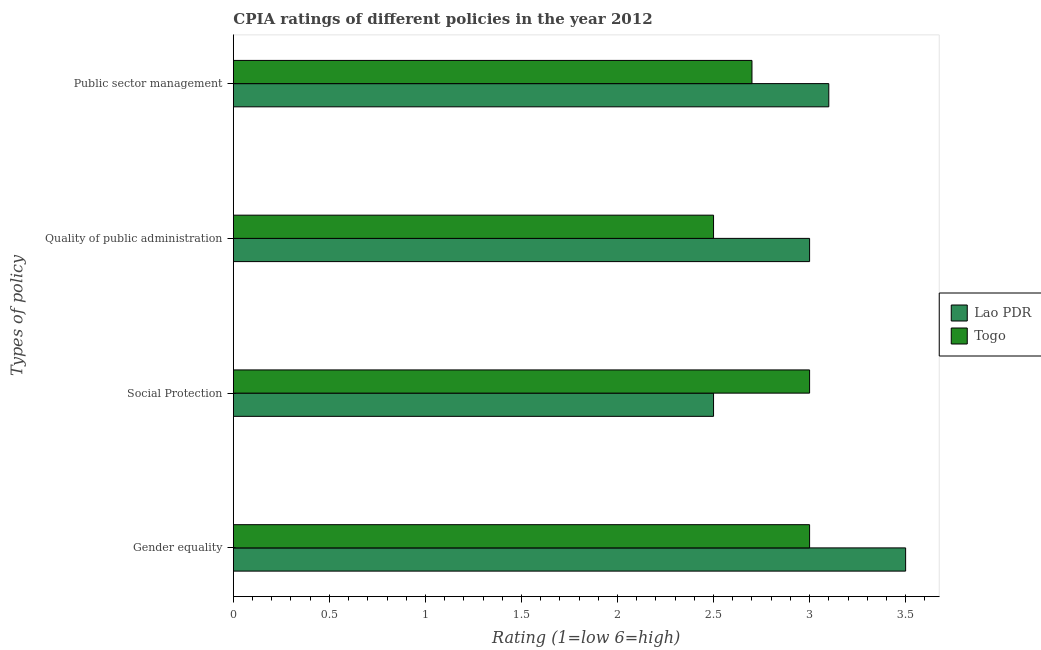How many groups of bars are there?
Your response must be concise. 4. Are the number of bars on each tick of the Y-axis equal?
Give a very brief answer. Yes. What is the label of the 3rd group of bars from the top?
Give a very brief answer. Social Protection. Across all countries, what is the maximum cpia rating of quality of public administration?
Provide a short and direct response. 3. Across all countries, what is the minimum cpia rating of social protection?
Keep it short and to the point. 2.5. In which country was the cpia rating of public sector management maximum?
Make the answer very short. Lao PDR. In which country was the cpia rating of gender equality minimum?
Make the answer very short. Togo. What is the difference between the cpia rating of public sector management in Lao PDR and the cpia rating of quality of public administration in Togo?
Provide a succinct answer. 0.6. What is the difference between the cpia rating of quality of public administration and cpia rating of public sector management in Lao PDR?
Ensure brevity in your answer.  -0.1. In how many countries, is the cpia rating of quality of public administration greater than 2.6 ?
Keep it short and to the point. 1. What is the ratio of the cpia rating of public sector management in Togo to that in Lao PDR?
Offer a terse response. 0.87. Is the cpia rating of social protection in Togo less than that in Lao PDR?
Your answer should be compact. No. What is the difference between the highest and the lowest cpia rating of quality of public administration?
Give a very brief answer. 0.5. In how many countries, is the cpia rating of quality of public administration greater than the average cpia rating of quality of public administration taken over all countries?
Provide a short and direct response. 1. Is the sum of the cpia rating of gender equality in Lao PDR and Togo greater than the maximum cpia rating of social protection across all countries?
Your response must be concise. Yes. What does the 2nd bar from the top in Social Protection represents?
Offer a very short reply. Lao PDR. What does the 2nd bar from the bottom in Gender equality represents?
Provide a succinct answer. Togo. Is it the case that in every country, the sum of the cpia rating of gender equality and cpia rating of social protection is greater than the cpia rating of quality of public administration?
Make the answer very short. Yes. Are all the bars in the graph horizontal?
Offer a very short reply. Yes. What is the difference between two consecutive major ticks on the X-axis?
Your answer should be very brief. 0.5. Where does the legend appear in the graph?
Your answer should be very brief. Center right. How many legend labels are there?
Offer a very short reply. 2. How are the legend labels stacked?
Keep it short and to the point. Vertical. What is the title of the graph?
Make the answer very short. CPIA ratings of different policies in the year 2012. Does "Mozambique" appear as one of the legend labels in the graph?
Provide a succinct answer. No. What is the label or title of the X-axis?
Offer a terse response. Rating (1=low 6=high). What is the label or title of the Y-axis?
Ensure brevity in your answer.  Types of policy. What is the Rating (1=low 6=high) in Togo in Social Protection?
Your response must be concise. 3. What is the Rating (1=low 6=high) in Lao PDR in Quality of public administration?
Your answer should be very brief. 3. What is the Rating (1=low 6=high) in Lao PDR in Public sector management?
Offer a very short reply. 3.1. What is the Rating (1=low 6=high) of Togo in Public sector management?
Your answer should be compact. 2.7. Across all Types of policy, what is the minimum Rating (1=low 6=high) in Lao PDR?
Provide a succinct answer. 2.5. What is the total Rating (1=low 6=high) of Lao PDR in the graph?
Your response must be concise. 12.1. What is the difference between the Rating (1=low 6=high) of Lao PDR in Gender equality and that in Social Protection?
Make the answer very short. 1. What is the difference between the Rating (1=low 6=high) in Lao PDR in Gender equality and that in Public sector management?
Provide a short and direct response. 0.4. What is the difference between the Rating (1=low 6=high) in Lao PDR in Social Protection and that in Quality of public administration?
Your answer should be compact. -0.5. What is the difference between the Rating (1=low 6=high) of Togo in Social Protection and that in Quality of public administration?
Ensure brevity in your answer.  0.5. What is the difference between the Rating (1=low 6=high) of Togo in Social Protection and that in Public sector management?
Provide a short and direct response. 0.3. What is the difference between the Rating (1=low 6=high) in Lao PDR in Quality of public administration and that in Public sector management?
Offer a terse response. -0.1. What is the average Rating (1=low 6=high) in Lao PDR per Types of policy?
Give a very brief answer. 3.02. What is the average Rating (1=low 6=high) of Togo per Types of policy?
Provide a short and direct response. 2.8. What is the difference between the Rating (1=low 6=high) of Lao PDR and Rating (1=low 6=high) of Togo in Social Protection?
Your answer should be compact. -0.5. What is the difference between the Rating (1=low 6=high) in Lao PDR and Rating (1=low 6=high) in Togo in Quality of public administration?
Ensure brevity in your answer.  0.5. What is the ratio of the Rating (1=low 6=high) of Lao PDR in Gender equality to that in Quality of public administration?
Your answer should be compact. 1.17. What is the ratio of the Rating (1=low 6=high) of Togo in Gender equality to that in Quality of public administration?
Your answer should be very brief. 1.2. What is the ratio of the Rating (1=low 6=high) in Lao PDR in Gender equality to that in Public sector management?
Make the answer very short. 1.13. What is the ratio of the Rating (1=low 6=high) of Togo in Gender equality to that in Public sector management?
Your answer should be very brief. 1.11. What is the ratio of the Rating (1=low 6=high) of Togo in Social Protection to that in Quality of public administration?
Offer a very short reply. 1.2. What is the ratio of the Rating (1=low 6=high) of Lao PDR in Social Protection to that in Public sector management?
Provide a succinct answer. 0.81. What is the ratio of the Rating (1=low 6=high) in Togo in Social Protection to that in Public sector management?
Give a very brief answer. 1.11. What is the ratio of the Rating (1=low 6=high) of Togo in Quality of public administration to that in Public sector management?
Ensure brevity in your answer.  0.93. What is the difference between the highest and the second highest Rating (1=low 6=high) in Lao PDR?
Keep it short and to the point. 0.4. 